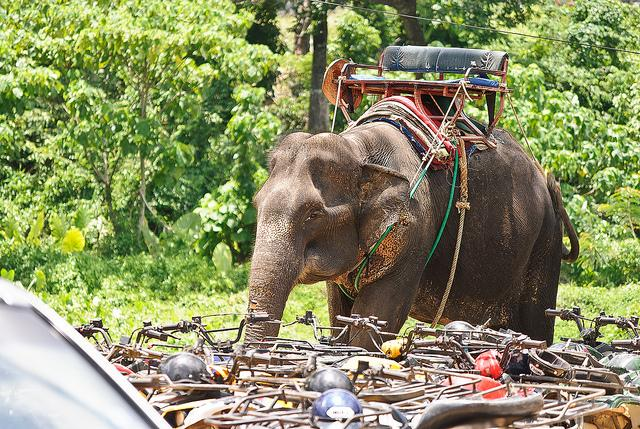What color is the back arch for the seat held by ropes on the back of this elephant?

Choices:
A) gold
B) blue
C) orange
D) green blue 